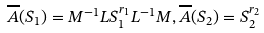Convert formula to latex. <formula><loc_0><loc_0><loc_500><loc_500>\overline { A } ( S _ { 1 } ) = M ^ { - 1 } L S ^ { r _ { 1 } } _ { 1 } L ^ { - 1 } M , \overline { A } ( S _ { 2 } ) = S ^ { r _ { 2 } } _ { 2 }</formula> 